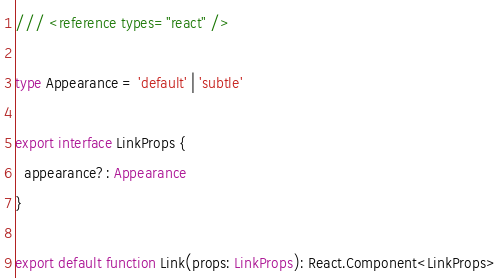Convert code to text. <code><loc_0><loc_0><loc_500><loc_500><_TypeScript_>/// <reference types="react" />

type Appearance = 'default' | 'subtle'

export interface LinkProps {
  appearance?: Appearance
}

export default function Link(props: LinkProps): React.Component<LinkProps>

</code> 